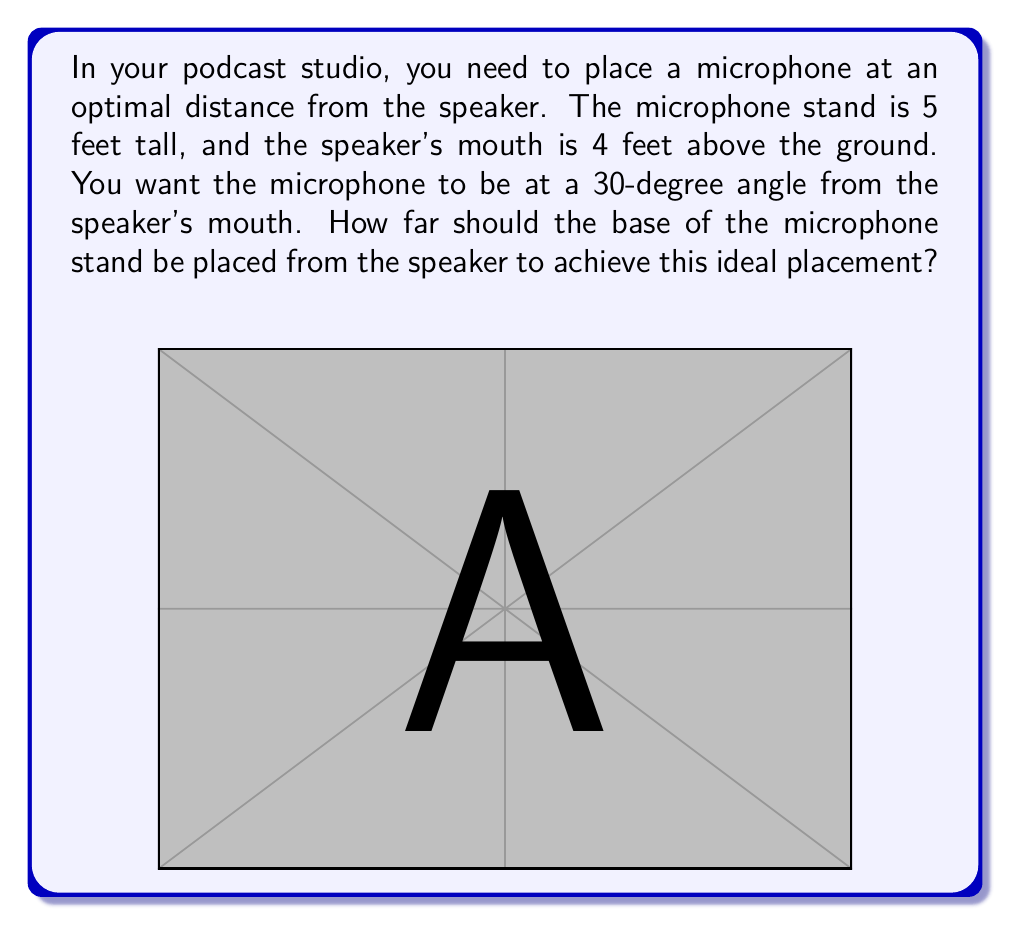What is the answer to this math problem? Let's approach this step-by-step using trigonometry:

1) First, let's identify the right triangle formed by the microphone, the speaker's mouth, and the floor.

2) We know:
   - The height difference between the mic and the speaker's mouth: $5 - 4 = 1$ foot
   - The angle from the speaker's mouth to the mic: 30°

3) In this right triangle:
   - The opposite side is the height difference (1 foot)
   - The hypotenuse is the line from the speaker's mouth to the mic
   - The angle we're interested in is 30°

4) We need to find the adjacent side, which is the distance from the speaker to the base of the mic stand.

5) We can use the tangent function:

   $$\tan(\theta) = \frac{\text{opposite}}{\text{adjacent}}$$

6) Substituting our values:

   $$\tan(30°) = \frac{1}{\text{adjacent}}$$

7) Solve for the adjacent side:

   $$\text{adjacent} = \frac{1}{\tan(30°)}$$

8) We know that $\tan(30°) = \frac{1}{\sqrt{3}}$, so:

   $$\text{adjacent} = \frac{1}{\frac{1}{\sqrt{3}}} = \sqrt{3}$$

9) Therefore, the distance from the speaker to the base of the mic stand should be $\sqrt{3}$ feet.
Answer: $\sqrt{3}$ feet 